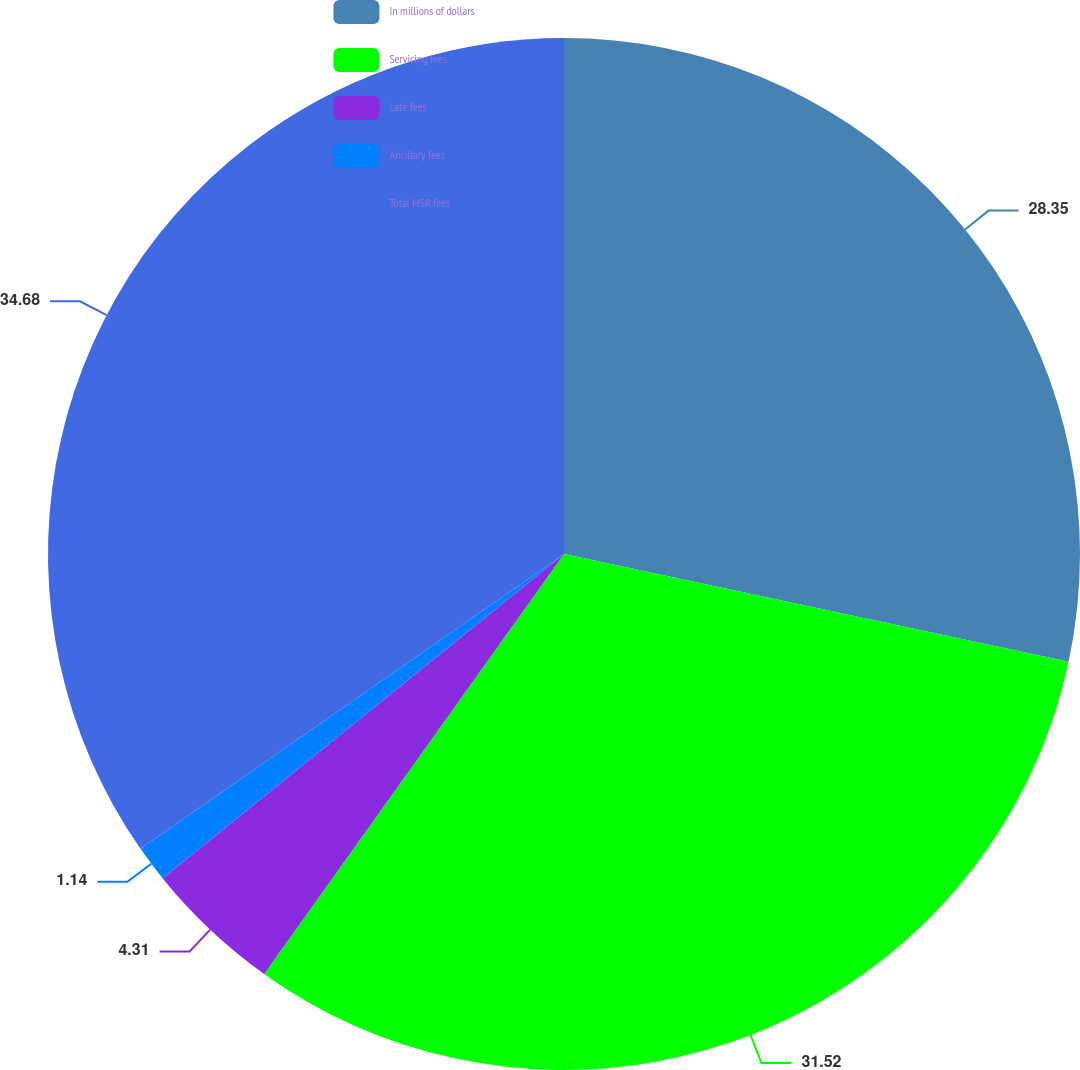<chart> <loc_0><loc_0><loc_500><loc_500><pie_chart><fcel>In millions of dollars<fcel>Servicing fees<fcel>Late fees<fcel>Ancillary fees<fcel>Total MSR fees<nl><fcel>28.35%<fcel>31.52%<fcel>4.31%<fcel>1.14%<fcel>34.68%<nl></chart> 